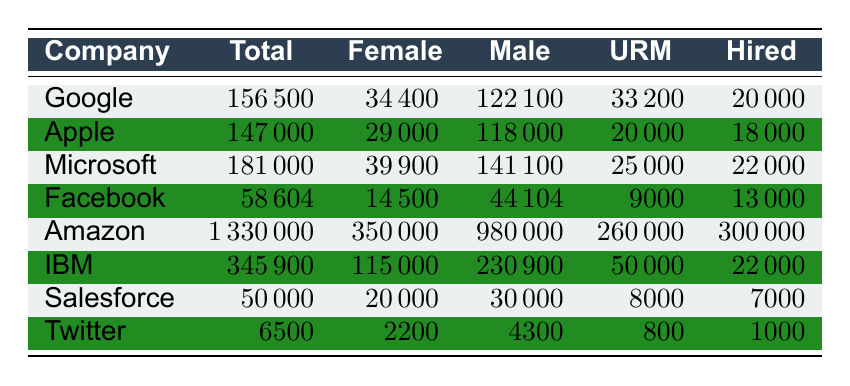What is the total number of employees at Google? The total number of employees for Google in the table is listed directly under the "Total" column. According to the data, Google has 156,500 total employees.
Answer: 156500 How many female employees does Amazon have? The number of female employees for Amazon is found in the "Female" column. According to the table, Amazon has 350,000 female employees.
Answer: 350000 Which company has the highest number of underrepresented minorities? To find the company with the highest number of underrepresented minorities, we look at the "URM" column for each company. Amazon has the highest number with 260,000 underrepresented minorities.
Answer: Amazon What is the percentage of female employees at Microsoft? We can calculate the percentage of female employees by dividing the number of female employees by the total number of employees and multiplying by 100. For Microsoft: (39,900 / 181,000) * 100 = 22.08%.
Answer: 22.08% Is Twitter's total employee count greater than Salesforce's? We can compare the "Total" column for both companies. Twitter has 6,500 employees, while Salesforce has 50,000 employees. Since 6,500 is less than 50,000, the statement is false.
Answer: No How many more male employees does IBM have compared to female employees? To find the difference in male and female employees at IBM, we subtract the number of female employees from the number of male employees: 230,900 (male) - 115,000 (female) = 115,900.
Answer: 115900 What is the total number of hired employees across all companies in the table? To find the total number of hired employees, we sum the "Hired" column for all companies: 20,000 + 18,000 + 22,000 + 13,000 + 300,000 + 22,000 + 7,000 + 1,000 = 403,000.
Answer: 403000 Do any companies have the same number of female employees? By inspecting the "Female" column for duplicates, we find that none of the companies listed have the same number of female employees. Therefore, the answer is false.
Answer: No What is the ratio of male to female employees at Apple? To calculate the ratio of male to female employees, we take the number of male employees and divide by the number of female employees: 118,000 (male) : 29,000 (female), simplifying gives us approximately 4.07:1.
Answer: 4.07:1 